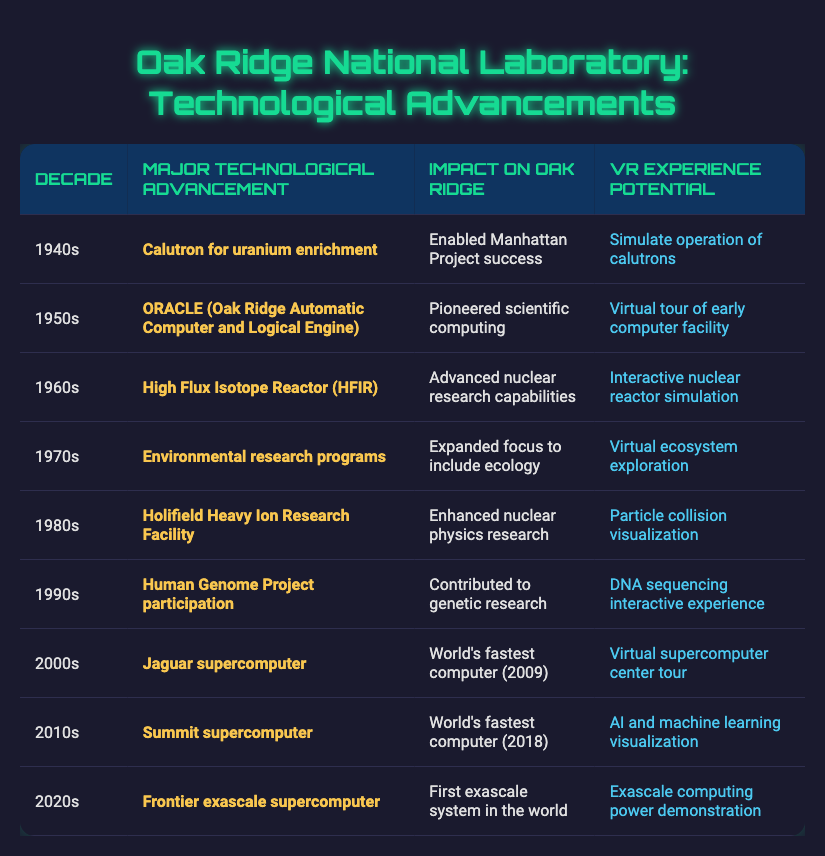What major technological advancement was introduced in the 1960s? The table indicates that the major technological advancement in the 1960s was the High Flux Isotope Reactor (HFIR).
Answer: High Flux Isotope Reactor (HFIR) Which decade saw the introduction of the first exascale supercomputer? According to the table, the first exascale supercomputer was introduced in the 2020s.
Answer: 2020s Did the 1990s advancements include any contribution to genetic research? Yes, the table states that the Human Genome Project participation in the 1990s contributed to genetic research.
Answer: Yes What is the impact of the ORACLE advancement on Oak Ridge? The impact of ORACLE, introduced in the 1950s, was that it pioneered scientific computing at Oak Ridge.
Answer: Pioneered scientific computing Which decade had both a supercomputer advancement and a VR experience focused on AI and machine learning? The 2010s had the Summit supercomputer advancement and provided a VR experience for AI and machine learning visualization.
Answer: 2010s What advancement in the 1970s expanded Oak Ridge's focus to include ecology? The advancement in the 1970s that expanded focus to include ecology was the environmental research programs.
Answer: Environmental research programs How many decades feature technological advancements related to supercomputers? There are three decades featuring technological advancements related to supercomputers: the 2000s (Jaguar), the 2010s (Summit), and the 2020s (Frontier). This provides a total of three decades.
Answer: 3 Compare the major advancements from the 1940s to the 1980s. What were their impacts? In the 1940s, the calutron for uranium enrichment enabled the Manhattan Project's success, while in the 1980s, the Holifield Heavy Ion Research Facility enhanced nuclear physics research. These advancements reflect a shift from wartime needs to fundamental scientific research.
Answer: Different impacts What was the VR experience potential related to the Jaguar supercomputer? The VR experience potential for the Jaguar supercomputer, which was the world's fastest computer in the 2000s, was a virtual supercomputer center tour.
Answer: Virtual supercomputer center tour 